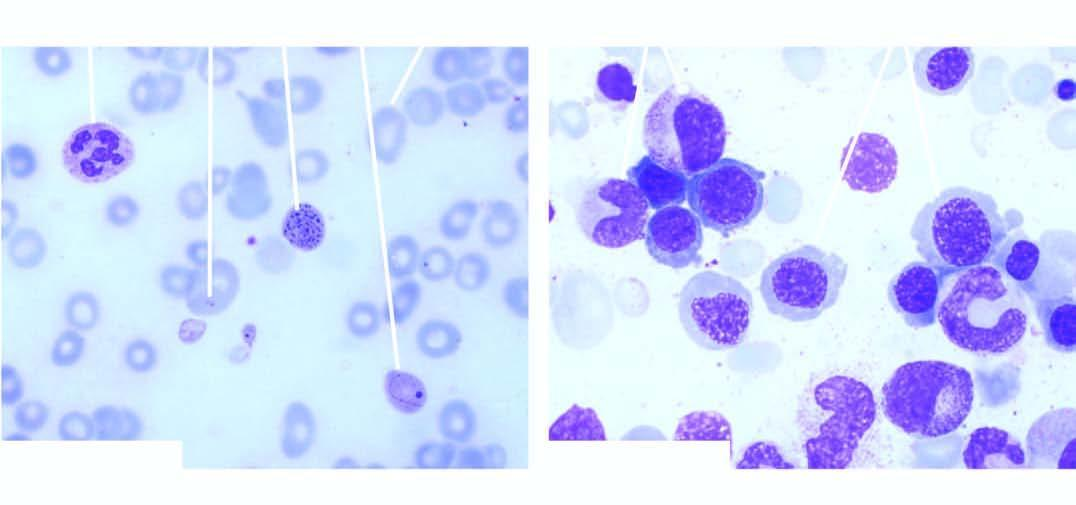what aspirate shows megaloblastic erythropoiesis?
Answer the question using a single word or phrase. Examination of bone marrow 